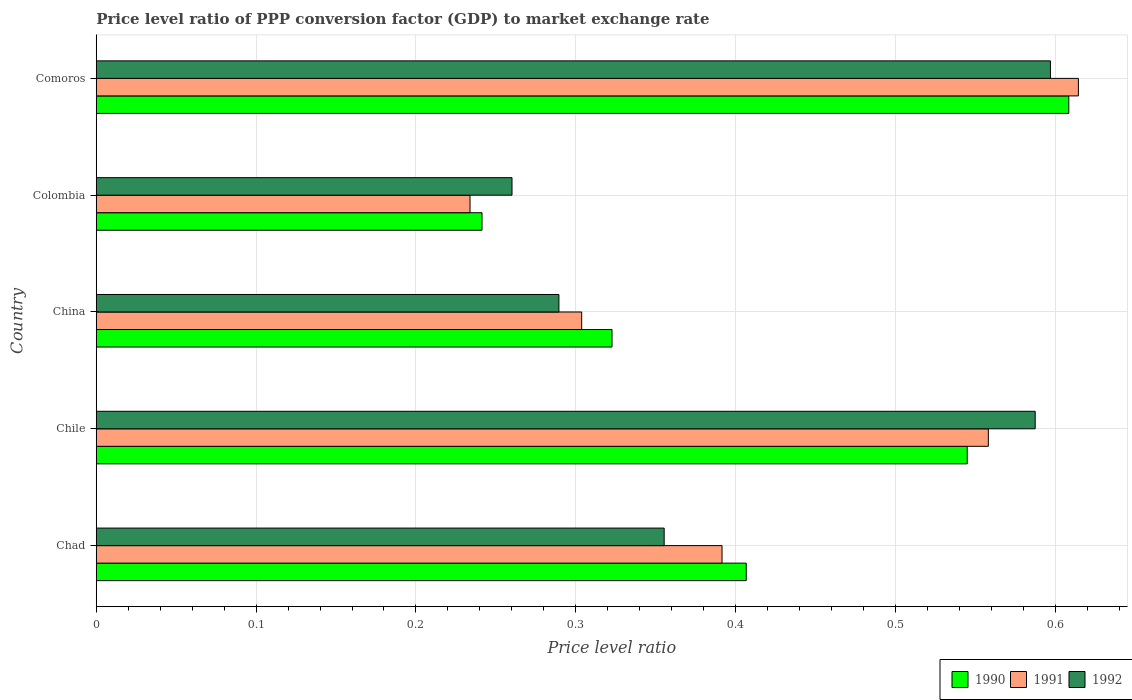How many different coloured bars are there?
Make the answer very short. 3. How many groups of bars are there?
Offer a terse response. 5. Are the number of bars on each tick of the Y-axis equal?
Provide a short and direct response. Yes. How many bars are there on the 5th tick from the top?
Make the answer very short. 3. What is the label of the 5th group of bars from the top?
Your answer should be compact. Chad. What is the price level ratio in 1991 in Chile?
Give a very brief answer. 0.56. Across all countries, what is the maximum price level ratio in 1990?
Your answer should be very brief. 0.61. Across all countries, what is the minimum price level ratio in 1991?
Give a very brief answer. 0.23. In which country was the price level ratio in 1992 maximum?
Offer a terse response. Comoros. In which country was the price level ratio in 1991 minimum?
Your answer should be compact. Colombia. What is the total price level ratio in 1992 in the graph?
Ensure brevity in your answer.  2.09. What is the difference between the price level ratio in 1991 in Chile and that in Comoros?
Offer a very short reply. -0.06. What is the difference between the price level ratio in 1990 in China and the price level ratio in 1992 in Chad?
Make the answer very short. -0.03. What is the average price level ratio in 1992 per country?
Make the answer very short. 0.42. What is the difference between the price level ratio in 1992 and price level ratio in 1991 in Chad?
Your answer should be compact. -0.04. What is the ratio of the price level ratio in 1990 in Chad to that in Comoros?
Your answer should be very brief. 0.67. Is the price level ratio in 1992 in Chad less than that in Colombia?
Your answer should be compact. No. What is the difference between the highest and the second highest price level ratio in 1991?
Offer a terse response. 0.06. What is the difference between the highest and the lowest price level ratio in 1990?
Offer a terse response. 0.37. Is the sum of the price level ratio in 1992 in Chad and Comoros greater than the maximum price level ratio in 1991 across all countries?
Keep it short and to the point. Yes. Are the values on the major ticks of X-axis written in scientific E-notation?
Offer a terse response. No. Where does the legend appear in the graph?
Provide a succinct answer. Bottom right. How are the legend labels stacked?
Give a very brief answer. Horizontal. What is the title of the graph?
Give a very brief answer. Price level ratio of PPP conversion factor (GDP) to market exchange rate. Does "1975" appear as one of the legend labels in the graph?
Keep it short and to the point. No. What is the label or title of the X-axis?
Provide a short and direct response. Price level ratio. What is the label or title of the Y-axis?
Give a very brief answer. Country. What is the Price level ratio of 1990 in Chad?
Your answer should be compact. 0.41. What is the Price level ratio of 1991 in Chad?
Your response must be concise. 0.39. What is the Price level ratio in 1992 in Chad?
Provide a succinct answer. 0.36. What is the Price level ratio in 1990 in Chile?
Keep it short and to the point. 0.54. What is the Price level ratio of 1991 in Chile?
Your response must be concise. 0.56. What is the Price level ratio of 1992 in Chile?
Offer a terse response. 0.59. What is the Price level ratio in 1990 in China?
Provide a short and direct response. 0.32. What is the Price level ratio in 1991 in China?
Your answer should be compact. 0.3. What is the Price level ratio of 1992 in China?
Your answer should be compact. 0.29. What is the Price level ratio of 1990 in Colombia?
Make the answer very short. 0.24. What is the Price level ratio in 1991 in Colombia?
Offer a very short reply. 0.23. What is the Price level ratio in 1992 in Colombia?
Keep it short and to the point. 0.26. What is the Price level ratio of 1990 in Comoros?
Provide a short and direct response. 0.61. What is the Price level ratio of 1991 in Comoros?
Keep it short and to the point. 0.61. What is the Price level ratio of 1992 in Comoros?
Provide a short and direct response. 0.6. Across all countries, what is the maximum Price level ratio of 1990?
Give a very brief answer. 0.61. Across all countries, what is the maximum Price level ratio in 1991?
Your answer should be compact. 0.61. Across all countries, what is the maximum Price level ratio in 1992?
Offer a very short reply. 0.6. Across all countries, what is the minimum Price level ratio in 1990?
Keep it short and to the point. 0.24. Across all countries, what is the minimum Price level ratio in 1991?
Your answer should be very brief. 0.23. Across all countries, what is the minimum Price level ratio in 1992?
Offer a terse response. 0.26. What is the total Price level ratio in 1990 in the graph?
Offer a very short reply. 2.12. What is the total Price level ratio in 1991 in the graph?
Keep it short and to the point. 2.1. What is the total Price level ratio in 1992 in the graph?
Your response must be concise. 2.09. What is the difference between the Price level ratio of 1990 in Chad and that in Chile?
Ensure brevity in your answer.  -0.14. What is the difference between the Price level ratio of 1991 in Chad and that in Chile?
Your answer should be compact. -0.17. What is the difference between the Price level ratio of 1992 in Chad and that in Chile?
Keep it short and to the point. -0.23. What is the difference between the Price level ratio in 1990 in Chad and that in China?
Your response must be concise. 0.08. What is the difference between the Price level ratio in 1991 in Chad and that in China?
Ensure brevity in your answer.  0.09. What is the difference between the Price level ratio of 1992 in Chad and that in China?
Offer a very short reply. 0.07. What is the difference between the Price level ratio of 1990 in Chad and that in Colombia?
Keep it short and to the point. 0.17. What is the difference between the Price level ratio of 1991 in Chad and that in Colombia?
Offer a very short reply. 0.16. What is the difference between the Price level ratio in 1992 in Chad and that in Colombia?
Ensure brevity in your answer.  0.1. What is the difference between the Price level ratio of 1990 in Chad and that in Comoros?
Your answer should be compact. -0.2. What is the difference between the Price level ratio of 1991 in Chad and that in Comoros?
Provide a succinct answer. -0.22. What is the difference between the Price level ratio in 1992 in Chad and that in Comoros?
Offer a terse response. -0.24. What is the difference between the Price level ratio in 1990 in Chile and that in China?
Offer a terse response. 0.22. What is the difference between the Price level ratio in 1991 in Chile and that in China?
Your answer should be compact. 0.25. What is the difference between the Price level ratio in 1992 in Chile and that in China?
Your response must be concise. 0.3. What is the difference between the Price level ratio of 1990 in Chile and that in Colombia?
Provide a succinct answer. 0.3. What is the difference between the Price level ratio in 1991 in Chile and that in Colombia?
Keep it short and to the point. 0.32. What is the difference between the Price level ratio of 1992 in Chile and that in Colombia?
Provide a succinct answer. 0.33. What is the difference between the Price level ratio in 1990 in Chile and that in Comoros?
Offer a very short reply. -0.06. What is the difference between the Price level ratio in 1991 in Chile and that in Comoros?
Provide a short and direct response. -0.06. What is the difference between the Price level ratio of 1992 in Chile and that in Comoros?
Offer a terse response. -0.01. What is the difference between the Price level ratio in 1990 in China and that in Colombia?
Your answer should be compact. 0.08. What is the difference between the Price level ratio of 1991 in China and that in Colombia?
Your answer should be very brief. 0.07. What is the difference between the Price level ratio in 1992 in China and that in Colombia?
Your response must be concise. 0.03. What is the difference between the Price level ratio in 1990 in China and that in Comoros?
Provide a succinct answer. -0.29. What is the difference between the Price level ratio in 1991 in China and that in Comoros?
Provide a succinct answer. -0.31. What is the difference between the Price level ratio of 1992 in China and that in Comoros?
Provide a succinct answer. -0.31. What is the difference between the Price level ratio in 1990 in Colombia and that in Comoros?
Provide a succinct answer. -0.37. What is the difference between the Price level ratio in 1991 in Colombia and that in Comoros?
Provide a short and direct response. -0.38. What is the difference between the Price level ratio in 1992 in Colombia and that in Comoros?
Provide a succinct answer. -0.34. What is the difference between the Price level ratio in 1990 in Chad and the Price level ratio in 1991 in Chile?
Make the answer very short. -0.15. What is the difference between the Price level ratio of 1990 in Chad and the Price level ratio of 1992 in Chile?
Provide a short and direct response. -0.18. What is the difference between the Price level ratio in 1991 in Chad and the Price level ratio in 1992 in Chile?
Ensure brevity in your answer.  -0.2. What is the difference between the Price level ratio in 1990 in Chad and the Price level ratio in 1991 in China?
Keep it short and to the point. 0.1. What is the difference between the Price level ratio of 1990 in Chad and the Price level ratio of 1992 in China?
Keep it short and to the point. 0.12. What is the difference between the Price level ratio in 1991 in Chad and the Price level ratio in 1992 in China?
Your response must be concise. 0.1. What is the difference between the Price level ratio in 1990 in Chad and the Price level ratio in 1991 in Colombia?
Keep it short and to the point. 0.17. What is the difference between the Price level ratio in 1990 in Chad and the Price level ratio in 1992 in Colombia?
Give a very brief answer. 0.15. What is the difference between the Price level ratio in 1991 in Chad and the Price level ratio in 1992 in Colombia?
Give a very brief answer. 0.13. What is the difference between the Price level ratio in 1990 in Chad and the Price level ratio in 1991 in Comoros?
Give a very brief answer. -0.21. What is the difference between the Price level ratio of 1990 in Chad and the Price level ratio of 1992 in Comoros?
Make the answer very short. -0.19. What is the difference between the Price level ratio in 1991 in Chad and the Price level ratio in 1992 in Comoros?
Make the answer very short. -0.21. What is the difference between the Price level ratio in 1990 in Chile and the Price level ratio in 1991 in China?
Offer a very short reply. 0.24. What is the difference between the Price level ratio in 1990 in Chile and the Price level ratio in 1992 in China?
Your response must be concise. 0.26. What is the difference between the Price level ratio in 1991 in Chile and the Price level ratio in 1992 in China?
Your answer should be compact. 0.27. What is the difference between the Price level ratio of 1990 in Chile and the Price level ratio of 1991 in Colombia?
Provide a short and direct response. 0.31. What is the difference between the Price level ratio of 1990 in Chile and the Price level ratio of 1992 in Colombia?
Provide a short and direct response. 0.28. What is the difference between the Price level ratio of 1991 in Chile and the Price level ratio of 1992 in Colombia?
Offer a very short reply. 0.3. What is the difference between the Price level ratio of 1990 in Chile and the Price level ratio of 1991 in Comoros?
Your answer should be compact. -0.07. What is the difference between the Price level ratio in 1990 in Chile and the Price level ratio in 1992 in Comoros?
Provide a short and direct response. -0.05. What is the difference between the Price level ratio in 1991 in Chile and the Price level ratio in 1992 in Comoros?
Offer a very short reply. -0.04. What is the difference between the Price level ratio in 1990 in China and the Price level ratio in 1991 in Colombia?
Keep it short and to the point. 0.09. What is the difference between the Price level ratio in 1990 in China and the Price level ratio in 1992 in Colombia?
Provide a succinct answer. 0.06. What is the difference between the Price level ratio in 1991 in China and the Price level ratio in 1992 in Colombia?
Offer a very short reply. 0.04. What is the difference between the Price level ratio in 1990 in China and the Price level ratio in 1991 in Comoros?
Your answer should be compact. -0.29. What is the difference between the Price level ratio of 1990 in China and the Price level ratio of 1992 in Comoros?
Provide a short and direct response. -0.27. What is the difference between the Price level ratio of 1991 in China and the Price level ratio of 1992 in Comoros?
Your answer should be compact. -0.29. What is the difference between the Price level ratio in 1990 in Colombia and the Price level ratio in 1991 in Comoros?
Your response must be concise. -0.37. What is the difference between the Price level ratio in 1990 in Colombia and the Price level ratio in 1992 in Comoros?
Offer a very short reply. -0.36. What is the difference between the Price level ratio of 1991 in Colombia and the Price level ratio of 1992 in Comoros?
Ensure brevity in your answer.  -0.36. What is the average Price level ratio in 1990 per country?
Your response must be concise. 0.42. What is the average Price level ratio in 1991 per country?
Give a very brief answer. 0.42. What is the average Price level ratio of 1992 per country?
Offer a very short reply. 0.42. What is the difference between the Price level ratio in 1990 and Price level ratio in 1991 in Chad?
Give a very brief answer. 0.02. What is the difference between the Price level ratio of 1990 and Price level ratio of 1992 in Chad?
Give a very brief answer. 0.05. What is the difference between the Price level ratio of 1991 and Price level ratio of 1992 in Chad?
Keep it short and to the point. 0.04. What is the difference between the Price level ratio of 1990 and Price level ratio of 1991 in Chile?
Offer a terse response. -0.01. What is the difference between the Price level ratio of 1990 and Price level ratio of 1992 in Chile?
Ensure brevity in your answer.  -0.04. What is the difference between the Price level ratio in 1991 and Price level ratio in 1992 in Chile?
Ensure brevity in your answer.  -0.03. What is the difference between the Price level ratio of 1990 and Price level ratio of 1991 in China?
Provide a succinct answer. 0.02. What is the difference between the Price level ratio of 1990 and Price level ratio of 1992 in China?
Offer a terse response. 0.03. What is the difference between the Price level ratio of 1991 and Price level ratio of 1992 in China?
Ensure brevity in your answer.  0.01. What is the difference between the Price level ratio of 1990 and Price level ratio of 1991 in Colombia?
Your answer should be compact. 0.01. What is the difference between the Price level ratio of 1990 and Price level ratio of 1992 in Colombia?
Offer a very short reply. -0.02. What is the difference between the Price level ratio of 1991 and Price level ratio of 1992 in Colombia?
Your response must be concise. -0.03. What is the difference between the Price level ratio in 1990 and Price level ratio in 1991 in Comoros?
Your answer should be compact. -0.01. What is the difference between the Price level ratio in 1990 and Price level ratio in 1992 in Comoros?
Provide a succinct answer. 0.01. What is the difference between the Price level ratio of 1991 and Price level ratio of 1992 in Comoros?
Offer a terse response. 0.02. What is the ratio of the Price level ratio of 1990 in Chad to that in Chile?
Offer a very short reply. 0.75. What is the ratio of the Price level ratio of 1991 in Chad to that in Chile?
Make the answer very short. 0.7. What is the ratio of the Price level ratio of 1992 in Chad to that in Chile?
Ensure brevity in your answer.  0.6. What is the ratio of the Price level ratio of 1990 in Chad to that in China?
Offer a terse response. 1.26. What is the ratio of the Price level ratio of 1991 in Chad to that in China?
Ensure brevity in your answer.  1.29. What is the ratio of the Price level ratio in 1992 in Chad to that in China?
Make the answer very short. 1.23. What is the ratio of the Price level ratio of 1990 in Chad to that in Colombia?
Provide a short and direct response. 1.69. What is the ratio of the Price level ratio of 1991 in Chad to that in Colombia?
Your response must be concise. 1.67. What is the ratio of the Price level ratio in 1992 in Chad to that in Colombia?
Provide a succinct answer. 1.37. What is the ratio of the Price level ratio of 1990 in Chad to that in Comoros?
Provide a succinct answer. 0.67. What is the ratio of the Price level ratio in 1991 in Chad to that in Comoros?
Offer a terse response. 0.64. What is the ratio of the Price level ratio in 1992 in Chad to that in Comoros?
Your answer should be very brief. 0.6. What is the ratio of the Price level ratio in 1990 in Chile to that in China?
Give a very brief answer. 1.69. What is the ratio of the Price level ratio of 1991 in Chile to that in China?
Ensure brevity in your answer.  1.84. What is the ratio of the Price level ratio in 1992 in Chile to that in China?
Provide a succinct answer. 2.03. What is the ratio of the Price level ratio of 1990 in Chile to that in Colombia?
Offer a terse response. 2.26. What is the ratio of the Price level ratio in 1991 in Chile to that in Colombia?
Make the answer very short. 2.39. What is the ratio of the Price level ratio in 1992 in Chile to that in Colombia?
Offer a very short reply. 2.26. What is the ratio of the Price level ratio of 1990 in Chile to that in Comoros?
Your answer should be very brief. 0.9. What is the ratio of the Price level ratio of 1991 in Chile to that in Comoros?
Your answer should be very brief. 0.91. What is the ratio of the Price level ratio of 1990 in China to that in Colombia?
Provide a short and direct response. 1.34. What is the ratio of the Price level ratio of 1991 in China to that in Colombia?
Make the answer very short. 1.3. What is the ratio of the Price level ratio of 1992 in China to that in Colombia?
Make the answer very short. 1.11. What is the ratio of the Price level ratio of 1990 in China to that in Comoros?
Provide a short and direct response. 0.53. What is the ratio of the Price level ratio of 1991 in China to that in Comoros?
Your response must be concise. 0.49. What is the ratio of the Price level ratio in 1992 in China to that in Comoros?
Your response must be concise. 0.48. What is the ratio of the Price level ratio in 1990 in Colombia to that in Comoros?
Provide a succinct answer. 0.4. What is the ratio of the Price level ratio in 1991 in Colombia to that in Comoros?
Offer a very short reply. 0.38. What is the ratio of the Price level ratio of 1992 in Colombia to that in Comoros?
Your answer should be compact. 0.44. What is the difference between the highest and the second highest Price level ratio of 1990?
Offer a terse response. 0.06. What is the difference between the highest and the second highest Price level ratio of 1991?
Offer a very short reply. 0.06. What is the difference between the highest and the second highest Price level ratio of 1992?
Give a very brief answer. 0.01. What is the difference between the highest and the lowest Price level ratio in 1990?
Ensure brevity in your answer.  0.37. What is the difference between the highest and the lowest Price level ratio of 1991?
Make the answer very short. 0.38. What is the difference between the highest and the lowest Price level ratio in 1992?
Your answer should be very brief. 0.34. 